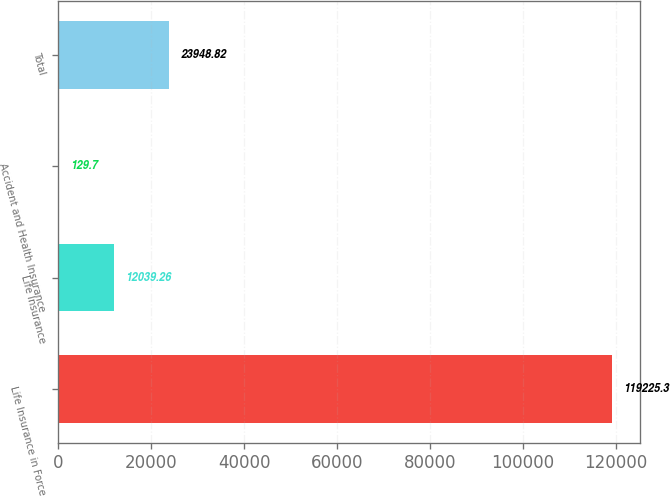Convert chart to OTSL. <chart><loc_0><loc_0><loc_500><loc_500><bar_chart><fcel>Life Insurance in Force<fcel>Life Insurance<fcel>Accident and Health Insurance<fcel>Total<nl><fcel>119225<fcel>12039.3<fcel>129.7<fcel>23948.8<nl></chart> 